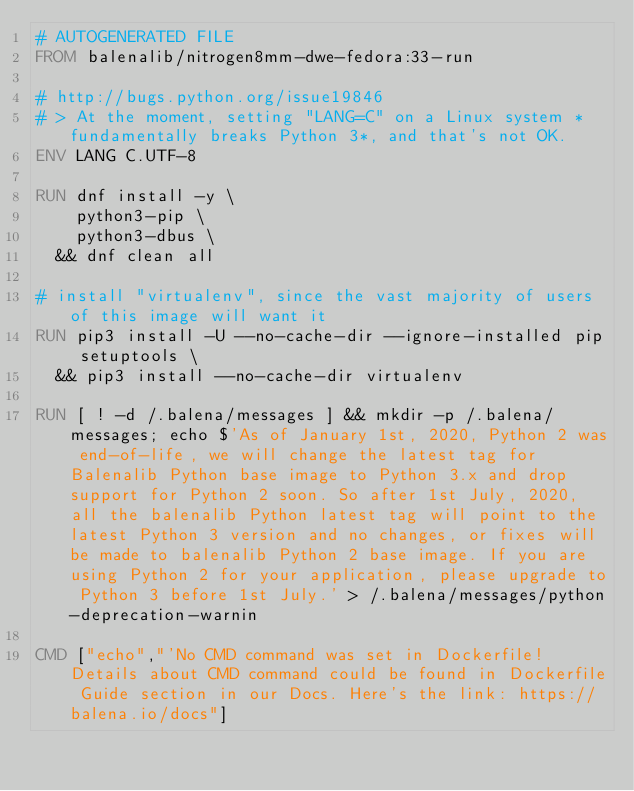<code> <loc_0><loc_0><loc_500><loc_500><_Dockerfile_># AUTOGENERATED FILE
FROM balenalib/nitrogen8mm-dwe-fedora:33-run

# http://bugs.python.org/issue19846
# > At the moment, setting "LANG=C" on a Linux system *fundamentally breaks Python 3*, and that's not OK.
ENV LANG C.UTF-8

RUN dnf install -y \
		python3-pip \
		python3-dbus \
	&& dnf clean all

# install "virtualenv", since the vast majority of users of this image will want it
RUN pip3 install -U --no-cache-dir --ignore-installed pip setuptools \
	&& pip3 install --no-cache-dir virtualenv

RUN [ ! -d /.balena/messages ] && mkdir -p /.balena/messages; echo $'As of January 1st, 2020, Python 2 was end-of-life, we will change the latest tag for Balenalib Python base image to Python 3.x and drop support for Python 2 soon. So after 1st July, 2020, all the balenalib Python latest tag will point to the latest Python 3 version and no changes, or fixes will be made to balenalib Python 2 base image. If you are using Python 2 for your application, please upgrade to Python 3 before 1st July.' > /.balena/messages/python-deprecation-warnin

CMD ["echo","'No CMD command was set in Dockerfile! Details about CMD command could be found in Dockerfile Guide section in our Docs. Here's the link: https://balena.io/docs"]
</code> 